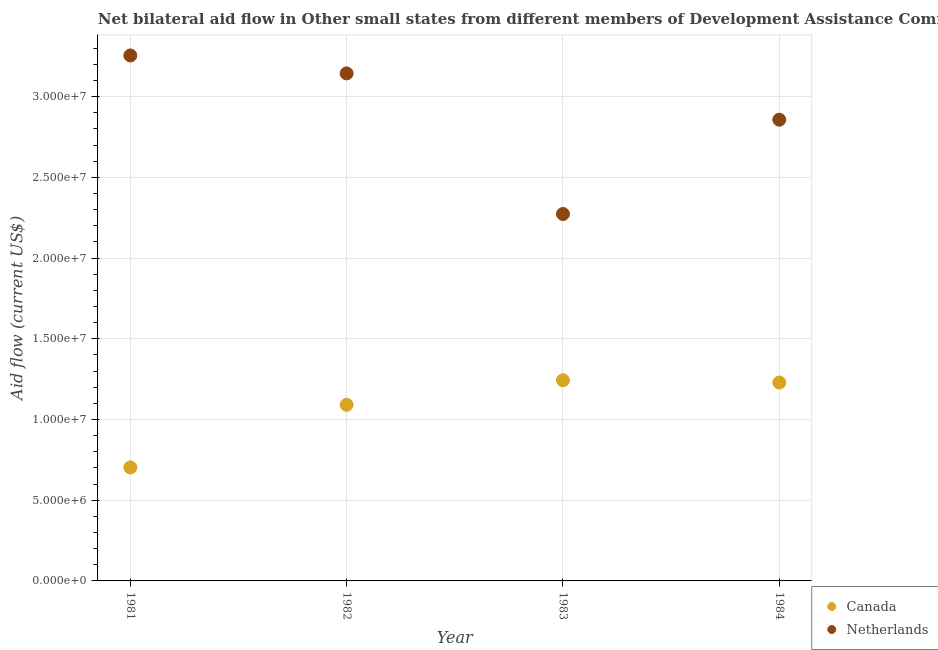How many different coloured dotlines are there?
Provide a succinct answer. 2. Is the number of dotlines equal to the number of legend labels?
Offer a very short reply. Yes. What is the amount of aid given by netherlands in 1984?
Give a very brief answer. 2.86e+07. Across all years, what is the maximum amount of aid given by netherlands?
Offer a terse response. 3.26e+07. Across all years, what is the minimum amount of aid given by canada?
Your answer should be compact. 7.03e+06. In which year was the amount of aid given by netherlands minimum?
Make the answer very short. 1983. What is the total amount of aid given by netherlands in the graph?
Your answer should be compact. 1.15e+08. What is the difference between the amount of aid given by netherlands in 1982 and that in 1984?
Ensure brevity in your answer.  2.87e+06. What is the difference between the amount of aid given by netherlands in 1983 and the amount of aid given by canada in 1984?
Ensure brevity in your answer.  1.04e+07. What is the average amount of aid given by netherlands per year?
Your answer should be compact. 2.88e+07. In the year 1981, what is the difference between the amount of aid given by netherlands and amount of aid given by canada?
Keep it short and to the point. 2.55e+07. What is the ratio of the amount of aid given by canada in 1982 to that in 1984?
Give a very brief answer. 0.89. Is the amount of aid given by canada in 1981 less than that in 1982?
Keep it short and to the point. Yes. Is the difference between the amount of aid given by canada in 1981 and 1982 greater than the difference between the amount of aid given by netherlands in 1981 and 1982?
Ensure brevity in your answer.  No. What is the difference between the highest and the second highest amount of aid given by canada?
Give a very brief answer. 1.40e+05. What is the difference between the highest and the lowest amount of aid given by netherlands?
Give a very brief answer. 9.82e+06. Is the sum of the amount of aid given by canada in 1981 and 1984 greater than the maximum amount of aid given by netherlands across all years?
Offer a very short reply. No. Does the amount of aid given by canada monotonically increase over the years?
Make the answer very short. No. Is the amount of aid given by canada strictly greater than the amount of aid given by netherlands over the years?
Offer a very short reply. No. Is the amount of aid given by canada strictly less than the amount of aid given by netherlands over the years?
Give a very brief answer. Yes. How many dotlines are there?
Your answer should be compact. 2. Where does the legend appear in the graph?
Give a very brief answer. Bottom right. How are the legend labels stacked?
Offer a terse response. Vertical. What is the title of the graph?
Give a very brief answer. Net bilateral aid flow in Other small states from different members of Development Assistance Committee. What is the Aid flow (current US$) of Canada in 1981?
Make the answer very short. 7.03e+06. What is the Aid flow (current US$) of Netherlands in 1981?
Offer a very short reply. 3.26e+07. What is the Aid flow (current US$) of Canada in 1982?
Your answer should be very brief. 1.09e+07. What is the Aid flow (current US$) of Netherlands in 1982?
Your answer should be compact. 3.14e+07. What is the Aid flow (current US$) of Canada in 1983?
Offer a very short reply. 1.24e+07. What is the Aid flow (current US$) in Netherlands in 1983?
Give a very brief answer. 2.27e+07. What is the Aid flow (current US$) of Canada in 1984?
Your answer should be very brief. 1.23e+07. What is the Aid flow (current US$) of Netherlands in 1984?
Your answer should be very brief. 2.86e+07. Across all years, what is the maximum Aid flow (current US$) in Canada?
Your answer should be compact. 1.24e+07. Across all years, what is the maximum Aid flow (current US$) of Netherlands?
Your answer should be compact. 3.26e+07. Across all years, what is the minimum Aid flow (current US$) of Canada?
Your answer should be compact. 7.03e+06. Across all years, what is the minimum Aid flow (current US$) of Netherlands?
Keep it short and to the point. 2.27e+07. What is the total Aid flow (current US$) in Canada in the graph?
Provide a succinct answer. 4.27e+07. What is the total Aid flow (current US$) of Netherlands in the graph?
Provide a succinct answer. 1.15e+08. What is the difference between the Aid flow (current US$) of Canada in 1981 and that in 1982?
Your answer should be compact. -3.88e+06. What is the difference between the Aid flow (current US$) of Netherlands in 1981 and that in 1982?
Your answer should be very brief. 1.11e+06. What is the difference between the Aid flow (current US$) in Canada in 1981 and that in 1983?
Offer a very short reply. -5.40e+06. What is the difference between the Aid flow (current US$) in Netherlands in 1981 and that in 1983?
Offer a very short reply. 9.82e+06. What is the difference between the Aid flow (current US$) in Canada in 1981 and that in 1984?
Give a very brief answer. -5.26e+06. What is the difference between the Aid flow (current US$) in Netherlands in 1981 and that in 1984?
Offer a terse response. 3.98e+06. What is the difference between the Aid flow (current US$) of Canada in 1982 and that in 1983?
Keep it short and to the point. -1.52e+06. What is the difference between the Aid flow (current US$) in Netherlands in 1982 and that in 1983?
Give a very brief answer. 8.71e+06. What is the difference between the Aid flow (current US$) in Canada in 1982 and that in 1984?
Make the answer very short. -1.38e+06. What is the difference between the Aid flow (current US$) of Netherlands in 1982 and that in 1984?
Offer a terse response. 2.87e+06. What is the difference between the Aid flow (current US$) of Canada in 1983 and that in 1984?
Provide a short and direct response. 1.40e+05. What is the difference between the Aid flow (current US$) in Netherlands in 1983 and that in 1984?
Offer a very short reply. -5.84e+06. What is the difference between the Aid flow (current US$) of Canada in 1981 and the Aid flow (current US$) of Netherlands in 1982?
Provide a short and direct response. -2.44e+07. What is the difference between the Aid flow (current US$) in Canada in 1981 and the Aid flow (current US$) in Netherlands in 1983?
Your answer should be very brief. -1.57e+07. What is the difference between the Aid flow (current US$) in Canada in 1981 and the Aid flow (current US$) in Netherlands in 1984?
Your response must be concise. -2.15e+07. What is the difference between the Aid flow (current US$) in Canada in 1982 and the Aid flow (current US$) in Netherlands in 1983?
Give a very brief answer. -1.18e+07. What is the difference between the Aid flow (current US$) in Canada in 1982 and the Aid flow (current US$) in Netherlands in 1984?
Provide a short and direct response. -1.77e+07. What is the difference between the Aid flow (current US$) of Canada in 1983 and the Aid flow (current US$) of Netherlands in 1984?
Your response must be concise. -1.61e+07. What is the average Aid flow (current US$) of Canada per year?
Your answer should be very brief. 1.07e+07. What is the average Aid flow (current US$) in Netherlands per year?
Provide a succinct answer. 2.88e+07. In the year 1981, what is the difference between the Aid flow (current US$) of Canada and Aid flow (current US$) of Netherlands?
Make the answer very short. -2.55e+07. In the year 1982, what is the difference between the Aid flow (current US$) of Canada and Aid flow (current US$) of Netherlands?
Ensure brevity in your answer.  -2.05e+07. In the year 1983, what is the difference between the Aid flow (current US$) in Canada and Aid flow (current US$) in Netherlands?
Offer a terse response. -1.03e+07. In the year 1984, what is the difference between the Aid flow (current US$) in Canada and Aid flow (current US$) in Netherlands?
Keep it short and to the point. -1.63e+07. What is the ratio of the Aid flow (current US$) in Canada in 1981 to that in 1982?
Offer a terse response. 0.64. What is the ratio of the Aid flow (current US$) in Netherlands in 1981 to that in 1982?
Your response must be concise. 1.04. What is the ratio of the Aid flow (current US$) in Canada in 1981 to that in 1983?
Keep it short and to the point. 0.57. What is the ratio of the Aid flow (current US$) of Netherlands in 1981 to that in 1983?
Your answer should be compact. 1.43. What is the ratio of the Aid flow (current US$) in Canada in 1981 to that in 1984?
Give a very brief answer. 0.57. What is the ratio of the Aid flow (current US$) in Netherlands in 1981 to that in 1984?
Provide a succinct answer. 1.14. What is the ratio of the Aid flow (current US$) in Canada in 1982 to that in 1983?
Your response must be concise. 0.88. What is the ratio of the Aid flow (current US$) of Netherlands in 1982 to that in 1983?
Offer a terse response. 1.38. What is the ratio of the Aid flow (current US$) in Canada in 1982 to that in 1984?
Provide a short and direct response. 0.89. What is the ratio of the Aid flow (current US$) of Netherlands in 1982 to that in 1984?
Provide a succinct answer. 1.1. What is the ratio of the Aid flow (current US$) in Canada in 1983 to that in 1984?
Your answer should be compact. 1.01. What is the ratio of the Aid flow (current US$) of Netherlands in 1983 to that in 1984?
Offer a very short reply. 0.8. What is the difference between the highest and the second highest Aid flow (current US$) in Canada?
Offer a terse response. 1.40e+05. What is the difference between the highest and the second highest Aid flow (current US$) of Netherlands?
Make the answer very short. 1.11e+06. What is the difference between the highest and the lowest Aid flow (current US$) of Canada?
Provide a short and direct response. 5.40e+06. What is the difference between the highest and the lowest Aid flow (current US$) of Netherlands?
Make the answer very short. 9.82e+06. 